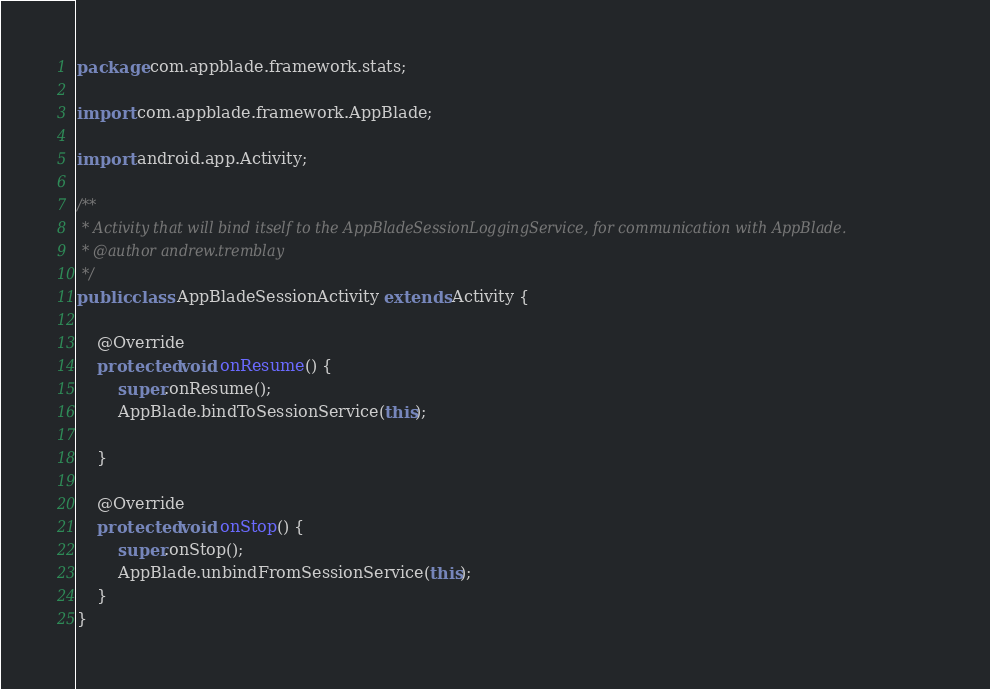<code> <loc_0><loc_0><loc_500><loc_500><_Java_>package com.appblade.framework.stats;

import com.appblade.framework.AppBlade;

import android.app.Activity;

/**
 * Activity that will bind itself to the AppBladeSessionLoggingService, for communication with AppBlade.
 * @author andrew.tremblay
 */
public class AppBladeSessionActivity extends Activity {
	
	@Override
	protected void onResume() {
		super.onResume();
		AppBlade.bindToSessionService(this);

	}

	@Override
	protected void onStop() {
		super.onStop();
		AppBlade.unbindFromSessionService(this);
	}
}
</code> 